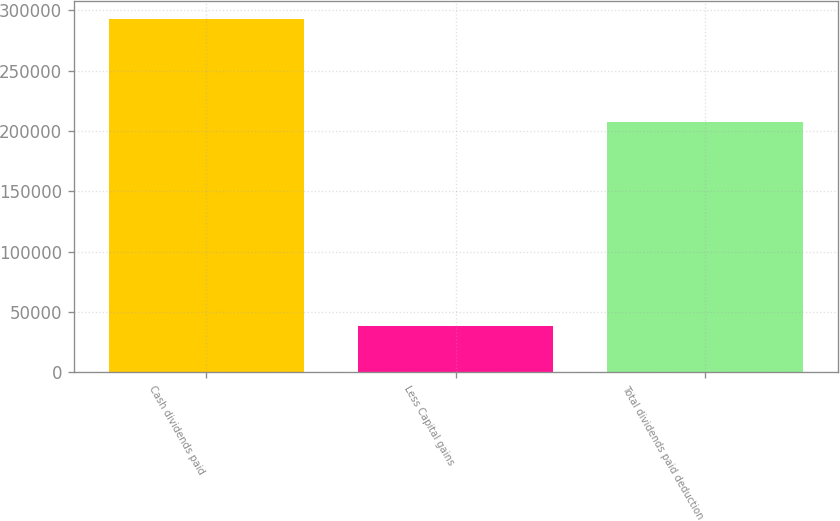Convert chart to OTSL. <chart><loc_0><loc_0><loc_500><loc_500><bar_chart><fcel>Cash dividends paid<fcel>Less Capital gains<fcel>Total dividends paid deduction<nl><fcel>292889<fcel>38655<fcel>207540<nl></chart> 